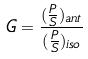<formula> <loc_0><loc_0><loc_500><loc_500>G = \frac { ( \frac { P } { S } ) _ { a n t } } { ( \frac { P } { S } ) _ { i s o } }</formula> 